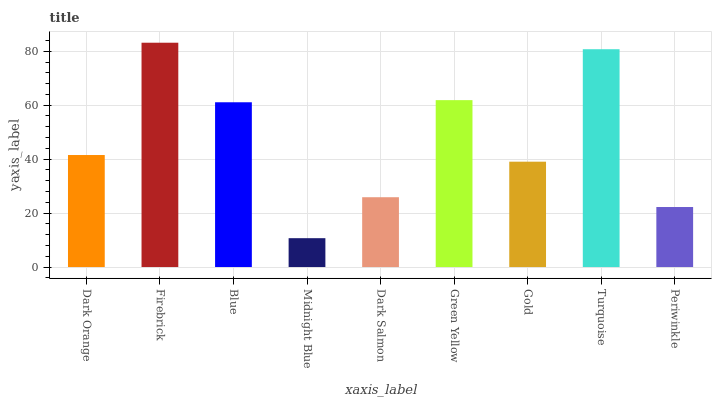Is Blue the minimum?
Answer yes or no. No. Is Blue the maximum?
Answer yes or no. No. Is Firebrick greater than Blue?
Answer yes or no. Yes. Is Blue less than Firebrick?
Answer yes or no. Yes. Is Blue greater than Firebrick?
Answer yes or no. No. Is Firebrick less than Blue?
Answer yes or no. No. Is Dark Orange the high median?
Answer yes or no. Yes. Is Dark Orange the low median?
Answer yes or no. Yes. Is Gold the high median?
Answer yes or no. No. Is Gold the low median?
Answer yes or no. No. 